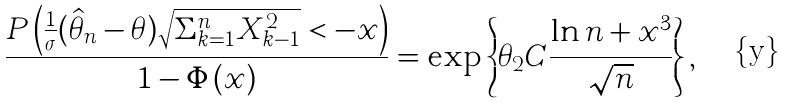<formula> <loc_0><loc_0><loc_500><loc_500>\frac { P \left ( \frac { 1 } { \sigma } ( \hat { \theta } _ { n } - \theta ) \sqrt { \Sigma _ { k = 1 } ^ { n } X _ { k - 1 } ^ { 2 } } < - x \right ) } { 1 - \Phi \left ( x \right ) } = \exp \left \{ \theta _ { 2 } C \frac { \ln n + x ^ { 3 } } { \sqrt { n } } \right \} ,</formula> 